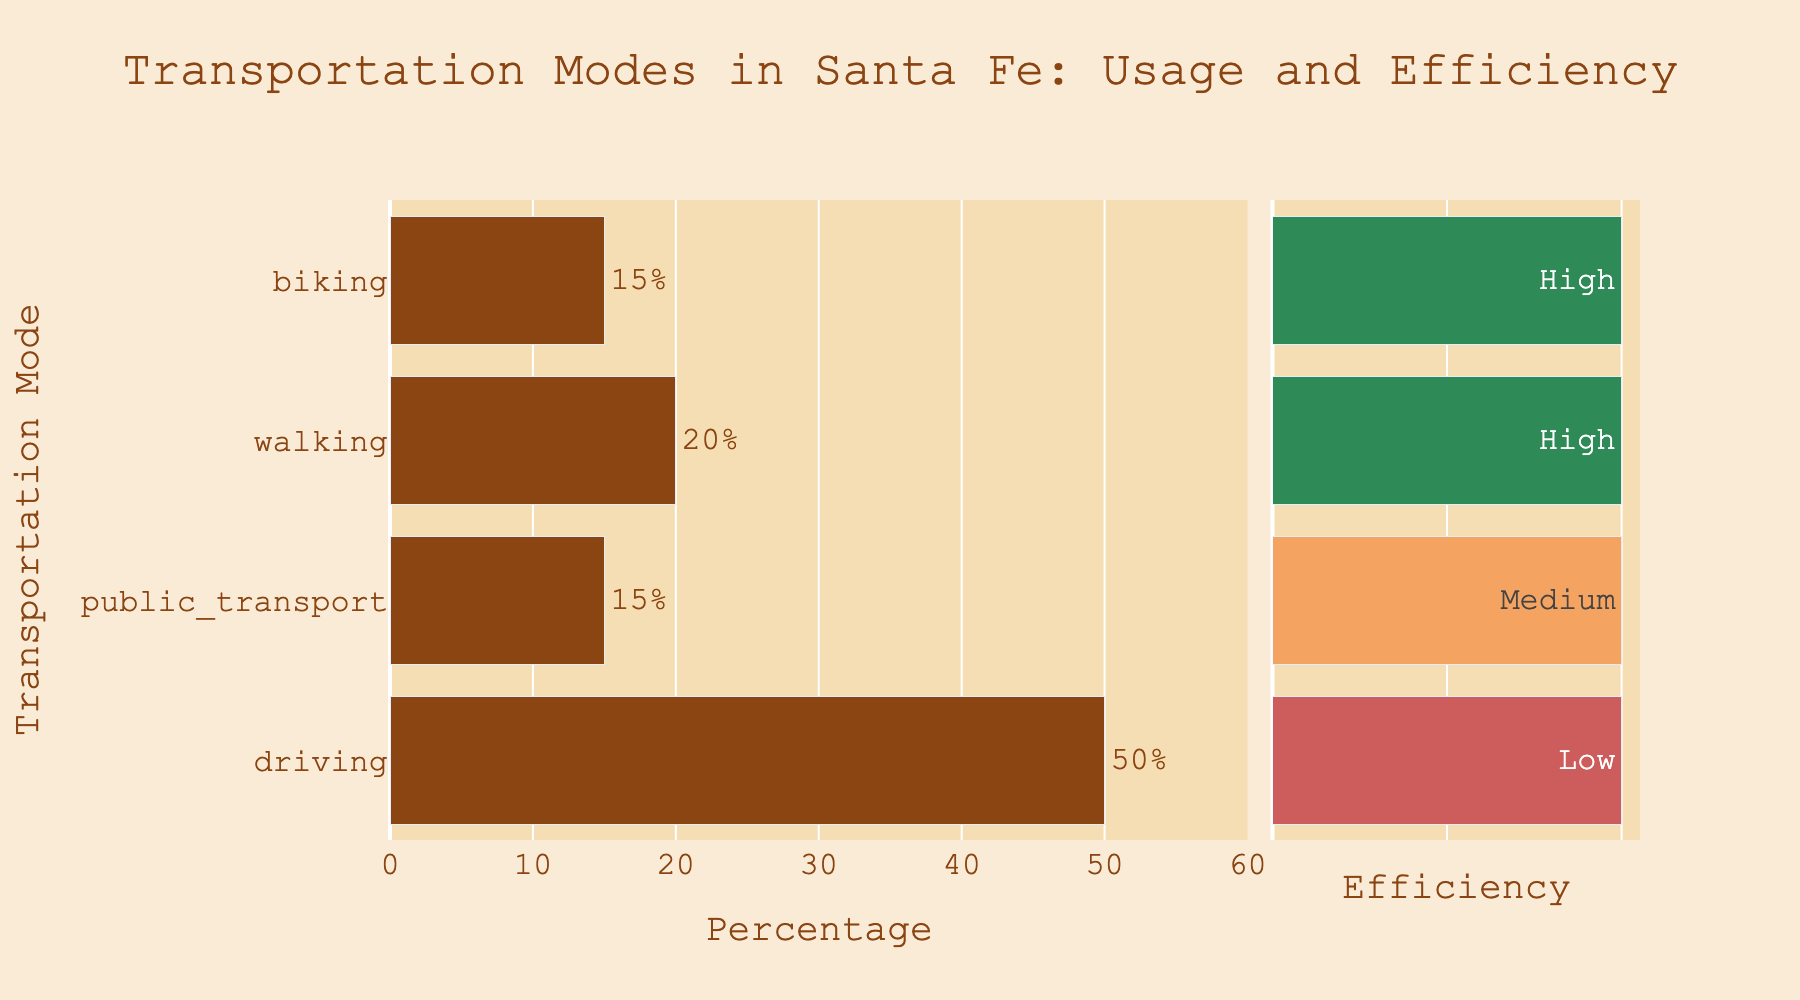What's the most common mode of transportation in Santa Fe based on usage percentage? According to the length of the bars on the left side, the longest bar represents driving with 50%, indicating it's the most common mode of transportation.
Answer: Driving Which transport modes have an efficiency rating of "high"? The bars on the right side colored in green represent modes with a "high" efficiency rating. These are walking and biking.
Answer: Walking, Biking What is the total percentage of residents using biking or public transport? Sum the percentages of biking (15%) and public transport (15%). So, 15% + 15% is 30%.
Answer: 30% Compare the percentages of walking and biking. Which is higher and by how much? Walking has a percentage of 20%, while biking has 15%. Subtract biking from walking: 20% - 15% gives 5%. Walking is higher by 5%.
Answer: Walking by 5% Which mode has the lowest efficiency rating, and what's its usage percentage? The red bar in the efficiency scale indicates the "low" rating. This color corresponds to driving, which has a usage percentage of 50%.
Answer: Driving, 50% What's the combined percentage for modes with a "medium" or "high" efficiency rating? Modes with "medium" and "high" efficiency ratings are public transport (15%), walking (20%), and biking (15%). Sum these percentages: 15% + 20% + 15% = 50%.
Answer: 50% Which transportation modes have an efficiency rating of "medium"? The color orange in the efficiency section represents the "medium" rating. The corresponding mode is public transport.
Answer: Public Transport Is the percentage of residents using walking greater than those using public transport? By how much? Walking has a 20% usage, and public transport has 15%. Subtract public transport from walking: 20% - 15% = 5%. Walking is greater by 5%.
Answer: Yes, by 5% 